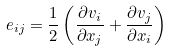<formula> <loc_0><loc_0><loc_500><loc_500>e _ { i j } = { \frac { 1 } { 2 } } \left ( { \frac { \partial v _ { i } } { \partial x _ { j } } } + { \frac { \partial v _ { j } } { \partial x _ { i } } } \right )</formula> 